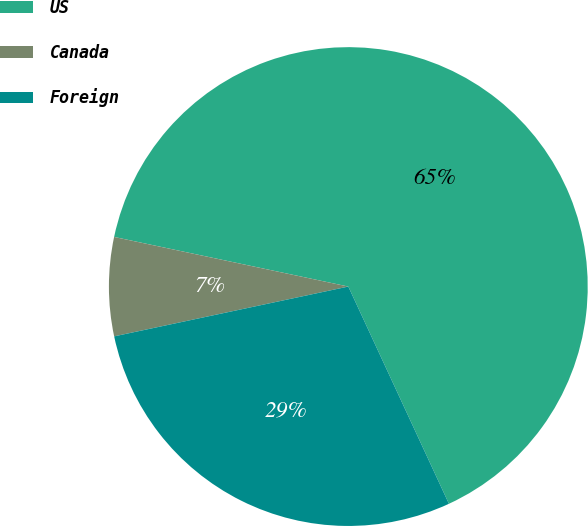<chart> <loc_0><loc_0><loc_500><loc_500><pie_chart><fcel>US<fcel>Canada<fcel>Foreign<nl><fcel>64.78%<fcel>6.66%<fcel>28.57%<nl></chart> 